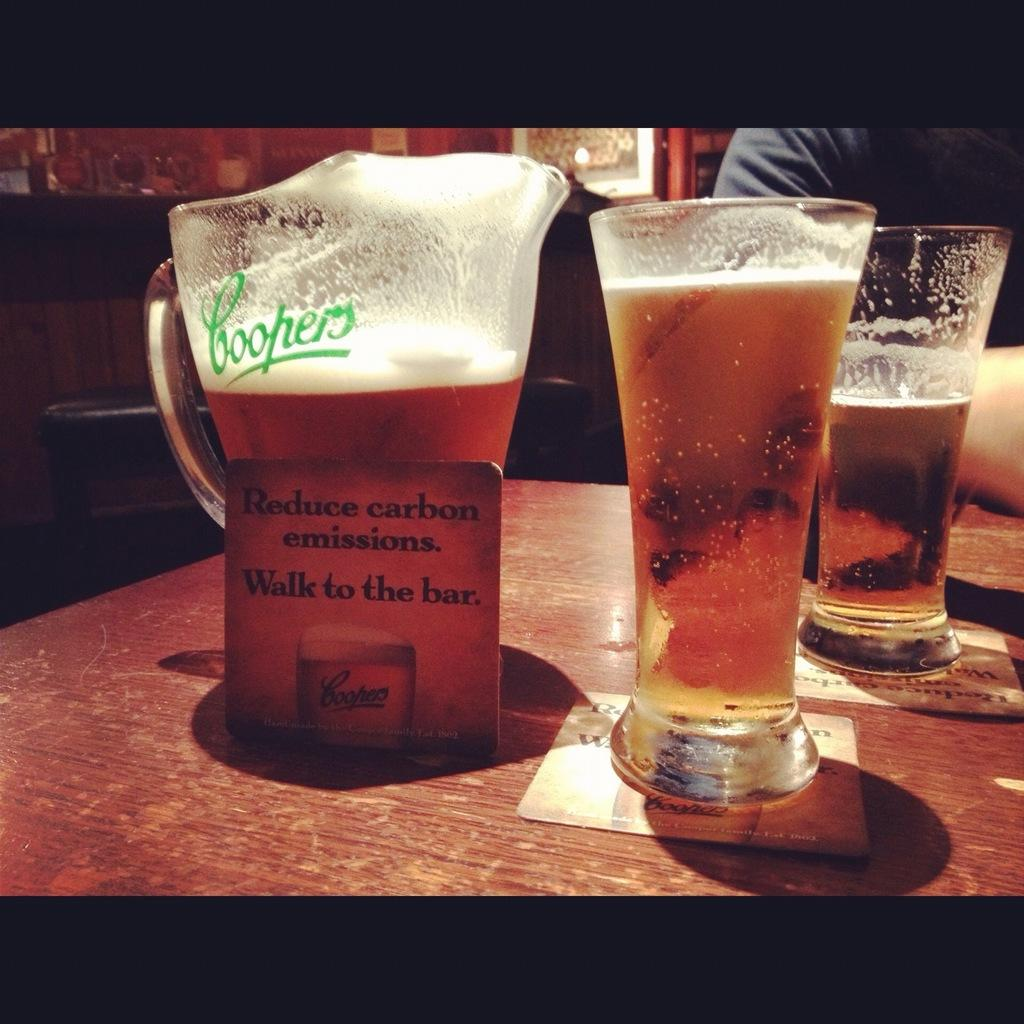What type of container is visible in the image? There is a glass mug in the image. How many glasses of drink are present in the image? There are two glasses of drink in the image. Where are the glass mug and glasses of drink located? The glass mug and glasses of drink are placed on a table. Can you describe the person in front of the table? The provided facts do not mention any details about the person in front of the table. What type of fish can be seen swimming in the lamp in the image? There is no fish or lamp present in the image. How does the rainstorm affect the glasses of drink in the image? There is no rainstorm present in the image, so it cannot affect the glasses of drink. 